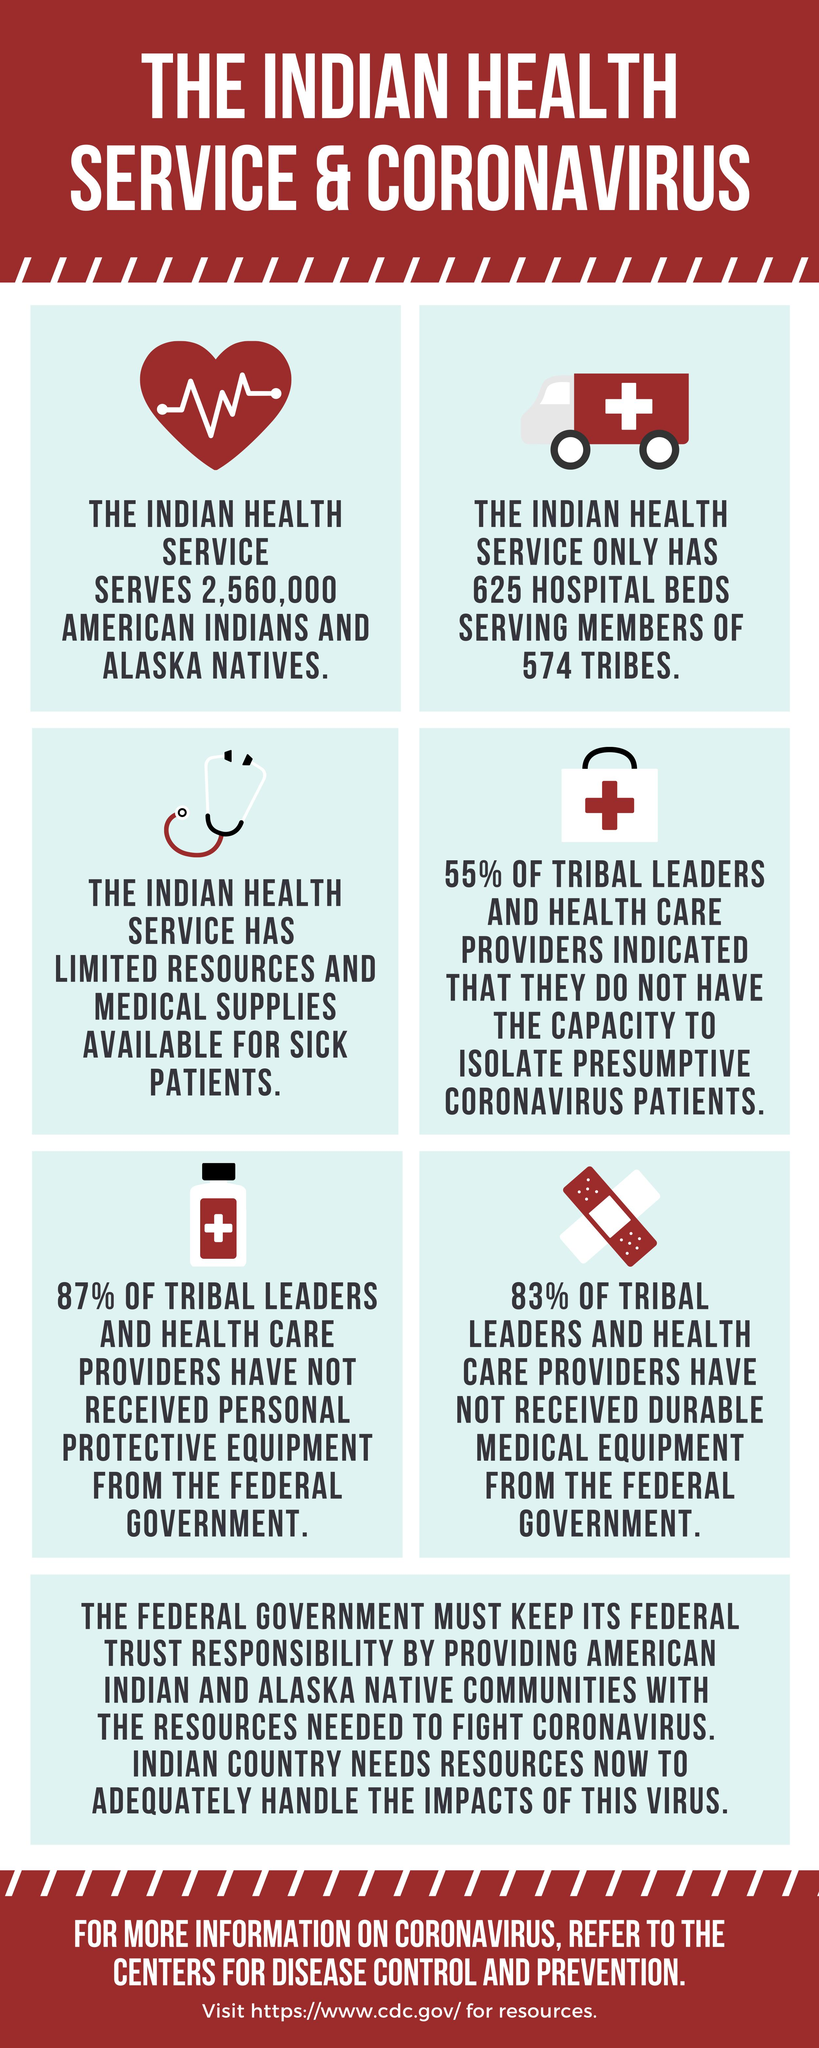Highlight a few significant elements in this photo. The lack of isolation facilities for coronavirus patients has been highlighted by tribal leaders and health care providers. According to 83% of tribal leaders and health care providers, they have not received durable medical equipment from the federal government. According to the leaders' responses, 55% indicated a lack of isolation facilities. The Indian Health Service has limited resources and medical supplies for sick patients. The tribal leaders and health care providers who have not received personal protective equipment from the federal government are in need of protection and care. 